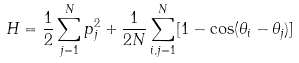Convert formula to latex. <formula><loc_0><loc_0><loc_500><loc_500>H = \frac { 1 } { 2 } \sum _ { j = 1 } ^ { N } p _ { j } ^ { 2 } + \frac { 1 } { 2 N } \sum _ { i , j = 1 } ^ { N } [ 1 - \cos ( \theta _ { i } - \theta _ { j } ) ]</formula> 